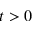Convert formula to latex. <formula><loc_0><loc_0><loc_500><loc_500>t > 0</formula> 